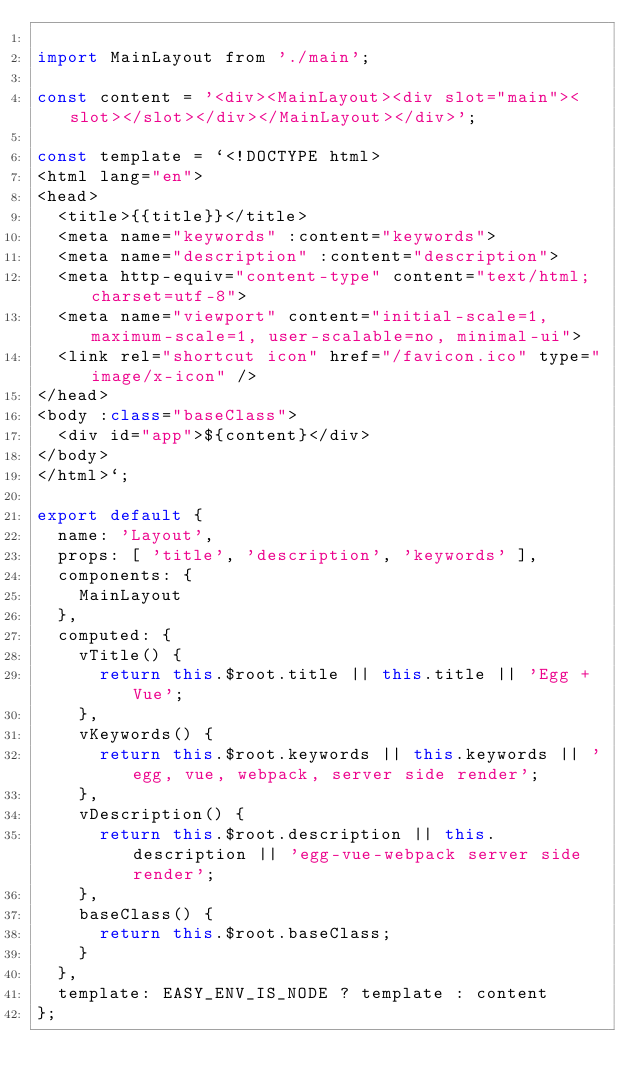Convert code to text. <code><loc_0><loc_0><loc_500><loc_500><_JavaScript_>
import MainLayout from './main';

const content = '<div><MainLayout><div slot="main"><slot></slot></div></MainLayout></div>';

const template = `<!DOCTYPE html>
<html lang="en">
<head>
  <title>{{title}}</title>
  <meta name="keywords" :content="keywords">
  <meta name="description" :content="description">
  <meta http-equiv="content-type" content="text/html;charset=utf-8">
  <meta name="viewport" content="initial-scale=1, maximum-scale=1, user-scalable=no, minimal-ui">
  <link rel="shortcut icon" href="/favicon.ico" type="image/x-icon" />
</head>
<body :class="baseClass">
  <div id="app">${content}</div>
</body>
</html>`;

export default {
  name: 'Layout',
  props: [ 'title', 'description', 'keywords' ],
  components: {
    MainLayout
  },
  computed: {
    vTitle() {
      return this.$root.title || this.title || 'Egg + Vue';
    },
    vKeywords() {
      return this.$root.keywords || this.keywords || 'egg, vue, webpack, server side render';
    },
    vDescription() {
      return this.$root.description || this.description || 'egg-vue-webpack server side render';
    },
    baseClass() {
      return this.$root.baseClass;
    }
  },
  template: EASY_ENV_IS_NODE ? template : content
};
</code> 